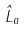Convert formula to latex. <formula><loc_0><loc_0><loc_500><loc_500>\hat { L } _ { a }</formula> 